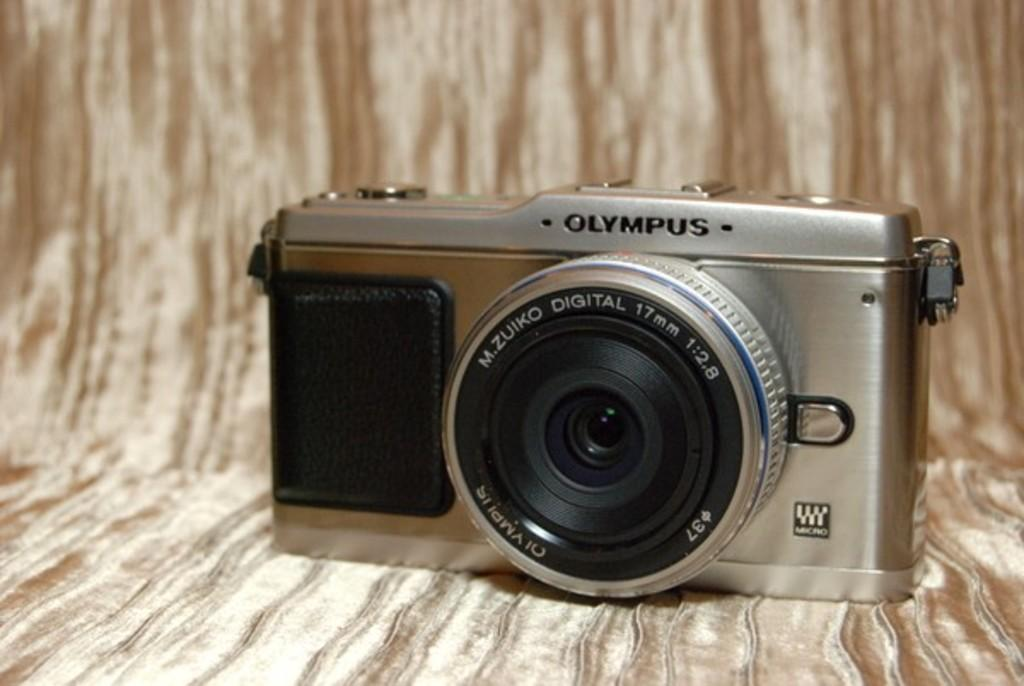What is the main object in the image? There is a camera in the image. What is the camera placed on? The camera is on a brown color cloth. Can you see any goat's toes in the image? There is no goat or its toes present in the image. 